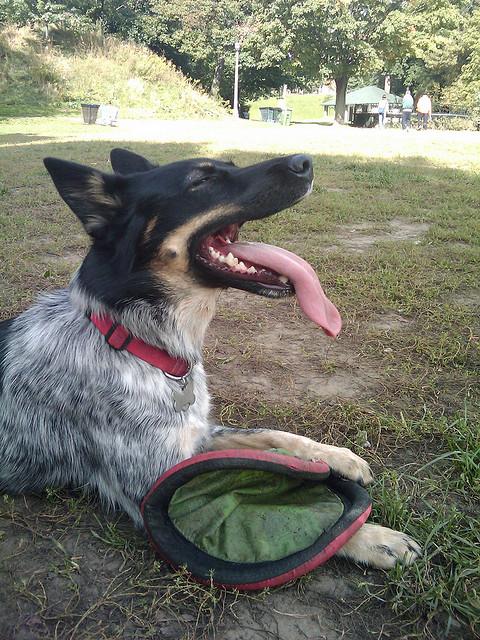Is the dog wearing a collar?
Short answer required. Yes. What is the dog holding?
Concise answer only. Frisbee. Is this dog sticking its tongue out?
Be succinct. Yes. 